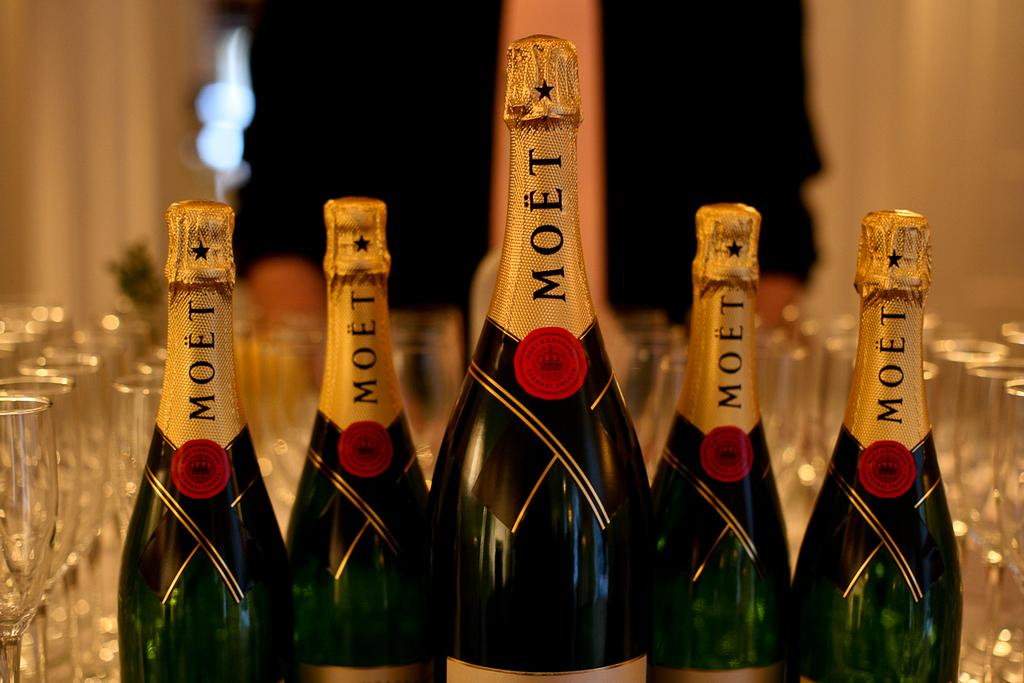<image>
Offer a succinct explanation of the picture presented. Wine bottles next to one another with the word MOET on the cover. 